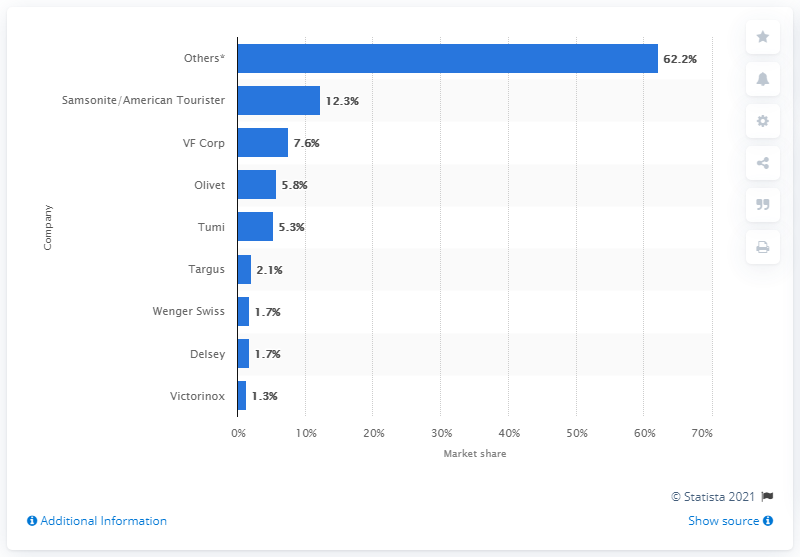Indicate a few pertinent items in this graphic. In 2010, the North American luggage market was dominated by Samsonite and American Tourister, with a combined market share of 12.3%. 